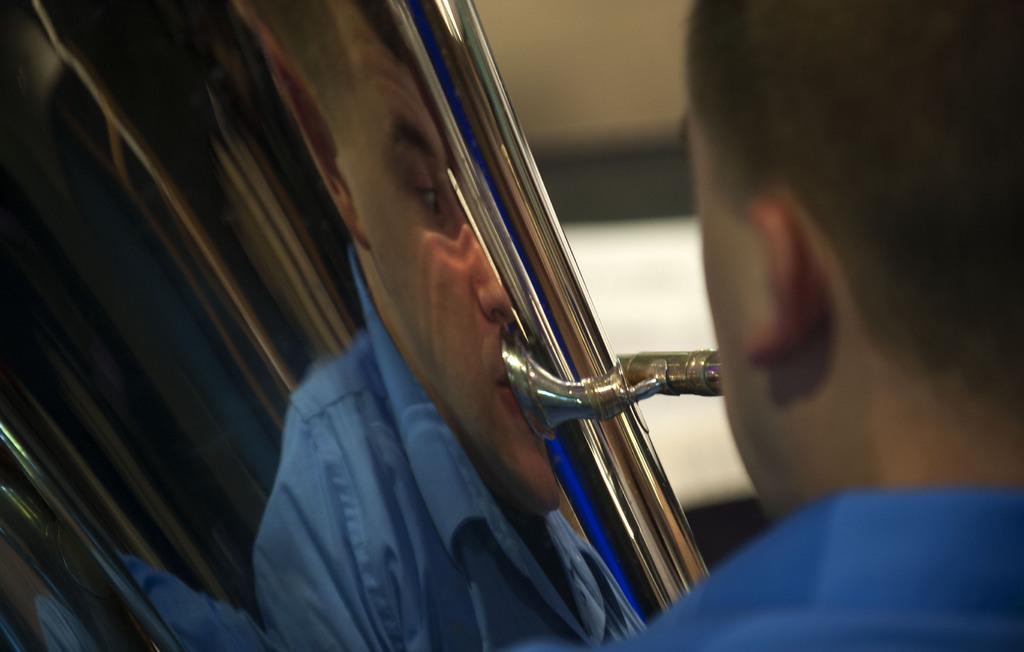What is the main subject of the image? There is a person in the image. What is the person doing in the image? The person is playing a trumpet. What type of hammer is the person using to play the trumpet in the image? There is no hammer present in the image; the person is playing a trumpet using their mouth and hands. How many roses can be seen in the image? There are no roses present in the image. 